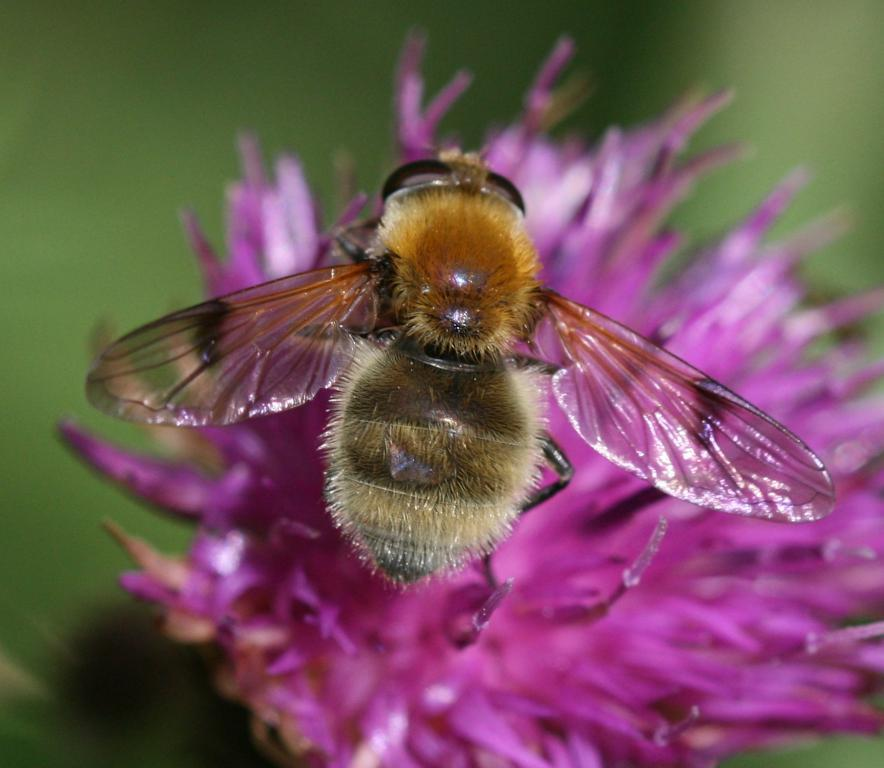What is the main subject of the image? There is a flower in the image. Is there anything interacting with the flower? Yes, there is a honey bee on the flower. How would you describe the background of the image? The background of the image is blurry. How many boats can be seen in the image? There are no boats present in the image. What type of powder is being used for learning in the image? There is no learning or powder present in the image. 